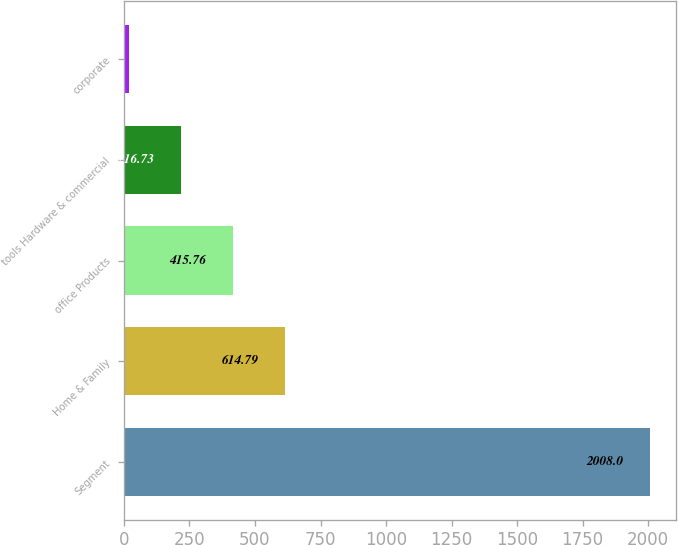Convert chart. <chart><loc_0><loc_0><loc_500><loc_500><bar_chart><fcel>Segment<fcel>Home & Family<fcel>office Products<fcel>tools Hardware & commercial<fcel>corporate<nl><fcel>2008<fcel>614.79<fcel>415.76<fcel>216.73<fcel>17.7<nl></chart> 